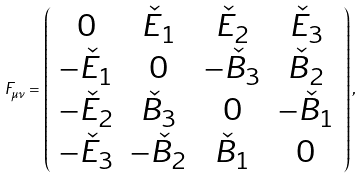Convert formula to latex. <formula><loc_0><loc_0><loc_500><loc_500>F _ { \mu \nu } = \left ( \begin{array} { c c c c } 0 & \check { E } _ { 1 } & \check { E } _ { 2 } & \check { E } _ { 3 } \\ - \check { E } _ { 1 } & 0 & - \check { B } _ { 3 } & \check { B } _ { 2 } \\ - \check { E } _ { 2 } & \check { B } _ { 3 } & 0 & - \check { B } _ { 1 } \\ - \check { E } _ { 3 } & - \check { B } _ { 2 } & \check { B } _ { 1 } & 0 \\ \end{array} \right ) ,</formula> 